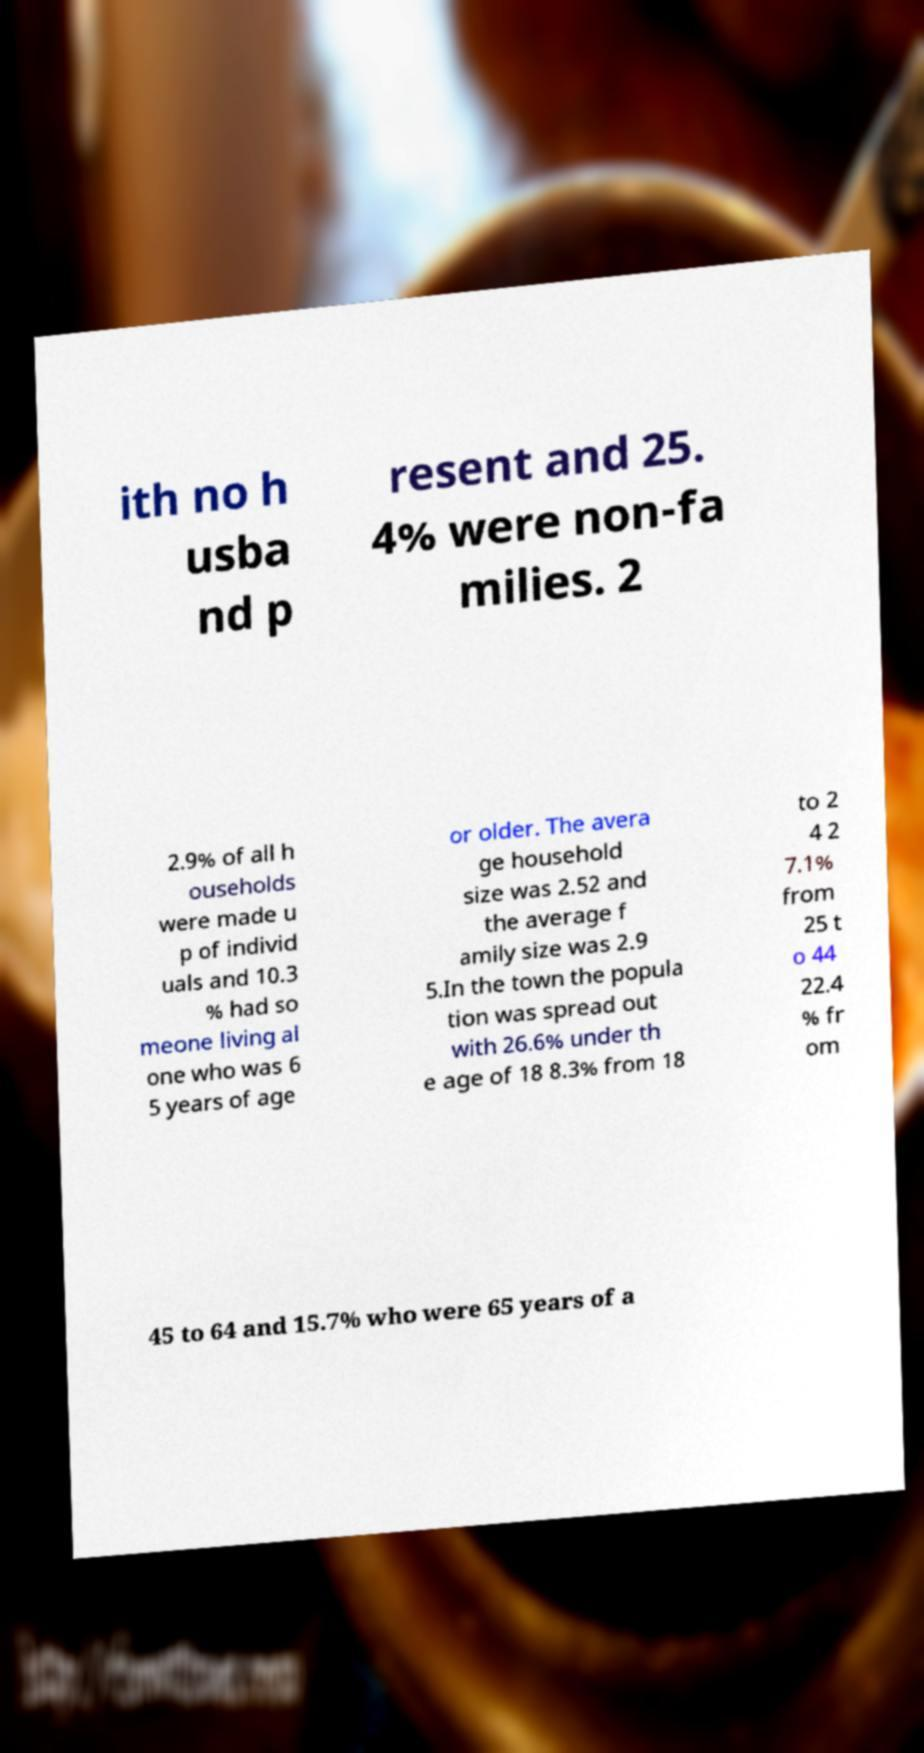What messages or text are displayed in this image? I need them in a readable, typed format. ith no h usba nd p resent and 25. 4% were non-fa milies. 2 2.9% of all h ouseholds were made u p of individ uals and 10.3 % had so meone living al one who was 6 5 years of age or older. The avera ge household size was 2.52 and the average f amily size was 2.9 5.In the town the popula tion was spread out with 26.6% under th e age of 18 8.3% from 18 to 2 4 2 7.1% from 25 t o 44 22.4 % fr om 45 to 64 and 15.7% who were 65 years of a 